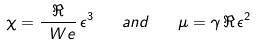Convert formula to latex. <formula><loc_0><loc_0><loc_500><loc_500>\chi = \frac { \Re } { \ W e } \, \epsilon ^ { 3 } \quad a n d \quad \mu = \gamma \, \Re \, \epsilon ^ { 2 }</formula> 